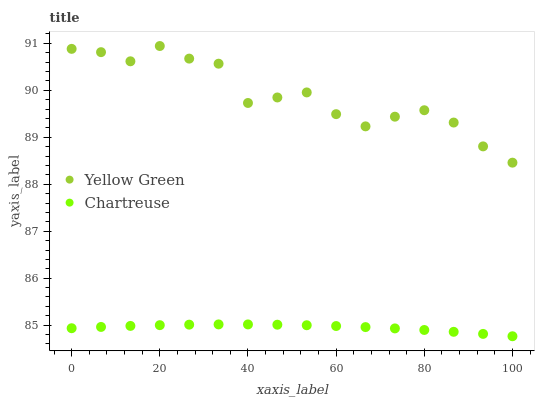Does Chartreuse have the minimum area under the curve?
Answer yes or no. Yes. Does Yellow Green have the maximum area under the curve?
Answer yes or no. Yes. Does Yellow Green have the minimum area under the curve?
Answer yes or no. No. Is Chartreuse the smoothest?
Answer yes or no. Yes. Is Yellow Green the roughest?
Answer yes or no. Yes. Is Yellow Green the smoothest?
Answer yes or no. No. Does Chartreuse have the lowest value?
Answer yes or no. Yes. Does Yellow Green have the lowest value?
Answer yes or no. No. Does Yellow Green have the highest value?
Answer yes or no. Yes. Is Chartreuse less than Yellow Green?
Answer yes or no. Yes. Is Yellow Green greater than Chartreuse?
Answer yes or no. Yes. Does Chartreuse intersect Yellow Green?
Answer yes or no. No. 